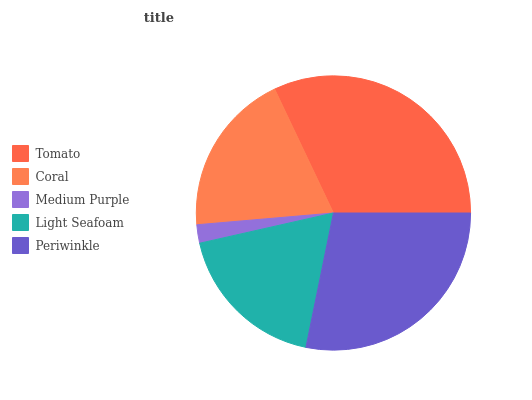Is Medium Purple the minimum?
Answer yes or no. Yes. Is Tomato the maximum?
Answer yes or no. Yes. Is Coral the minimum?
Answer yes or no. No. Is Coral the maximum?
Answer yes or no. No. Is Tomato greater than Coral?
Answer yes or no. Yes. Is Coral less than Tomato?
Answer yes or no. Yes. Is Coral greater than Tomato?
Answer yes or no. No. Is Tomato less than Coral?
Answer yes or no. No. Is Coral the high median?
Answer yes or no. Yes. Is Coral the low median?
Answer yes or no. Yes. Is Tomato the high median?
Answer yes or no. No. Is Tomato the low median?
Answer yes or no. No. 